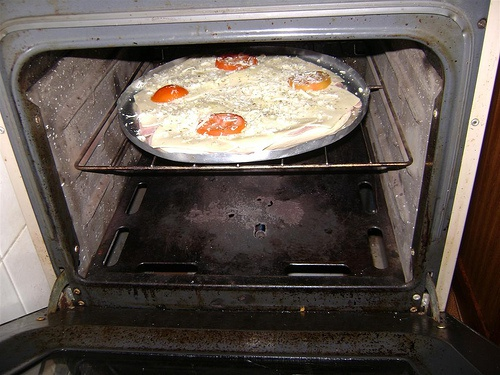Describe the objects in this image and their specific colors. I can see oven in black, gray, darkgray, and ivory tones and pizza in gray, beige, tan, and darkgray tones in this image. 